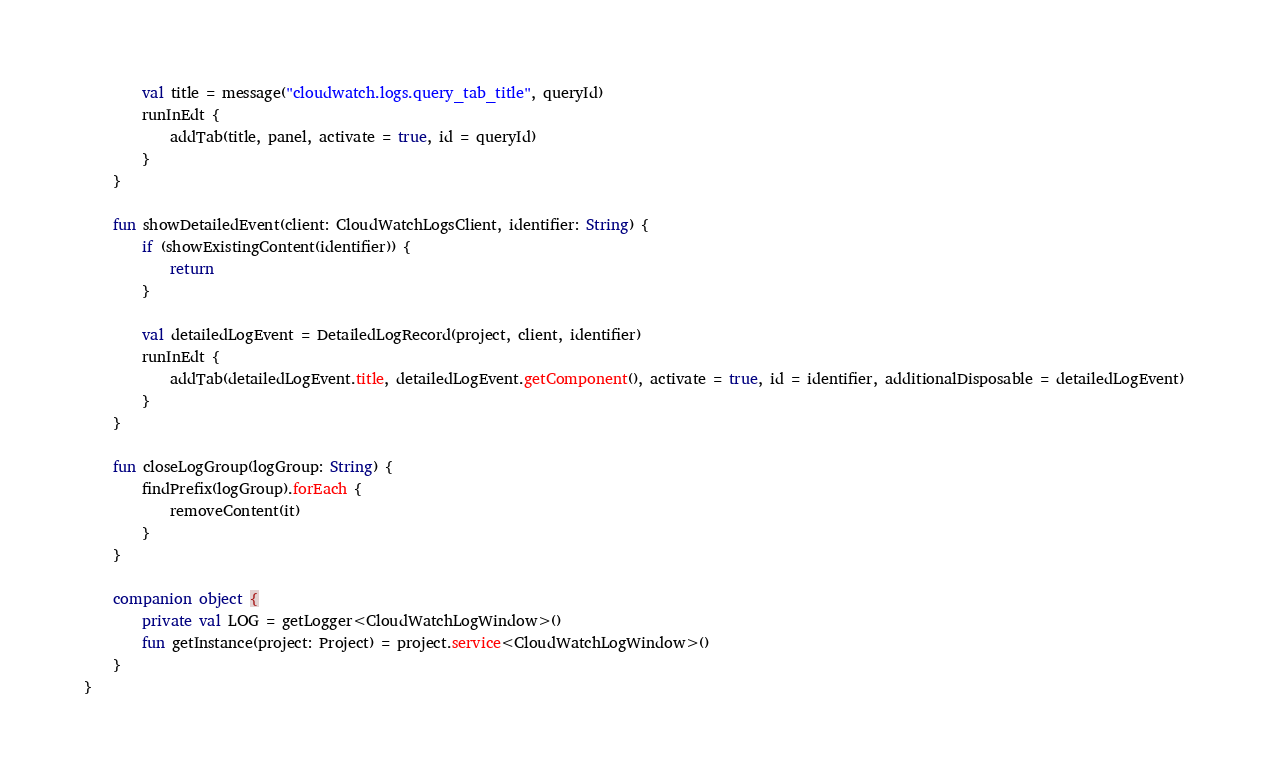<code> <loc_0><loc_0><loc_500><loc_500><_Kotlin_>        val title = message("cloudwatch.logs.query_tab_title", queryId)
        runInEdt {
            addTab(title, panel, activate = true, id = queryId)
        }
    }

    fun showDetailedEvent(client: CloudWatchLogsClient, identifier: String) {
        if (showExistingContent(identifier)) {
            return
        }

        val detailedLogEvent = DetailedLogRecord(project, client, identifier)
        runInEdt {
            addTab(detailedLogEvent.title, detailedLogEvent.getComponent(), activate = true, id = identifier, additionalDisposable = detailedLogEvent)
        }
    }

    fun closeLogGroup(logGroup: String) {
        findPrefix(logGroup).forEach {
            removeContent(it)
        }
    }

    companion object {
        private val LOG = getLogger<CloudWatchLogWindow>()
        fun getInstance(project: Project) = project.service<CloudWatchLogWindow>()
    }
}
</code> 